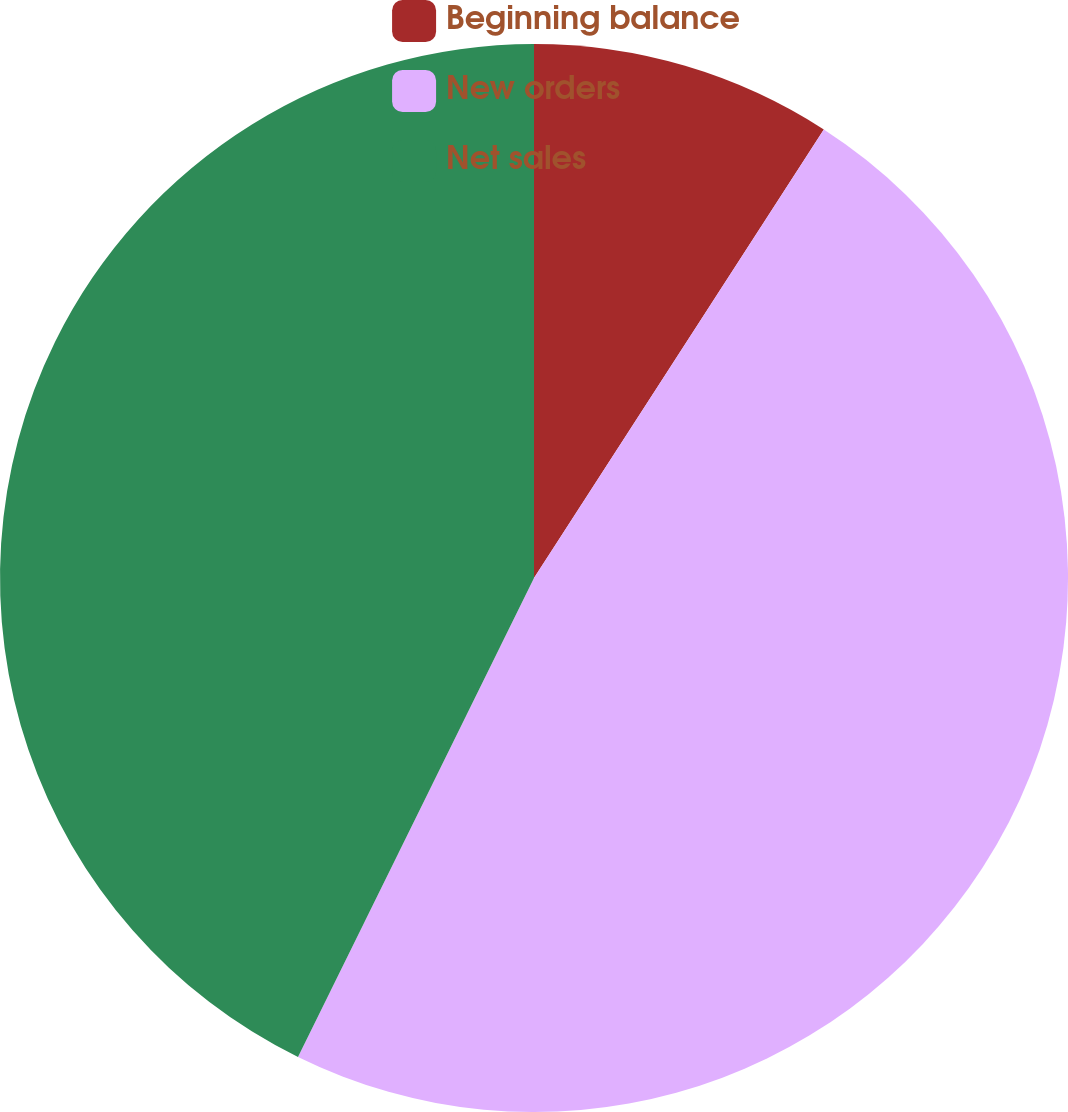<chart> <loc_0><loc_0><loc_500><loc_500><pie_chart><fcel>Beginning balance<fcel>New orders<fcel>Net sales<nl><fcel>9.13%<fcel>48.15%<fcel>42.71%<nl></chart> 